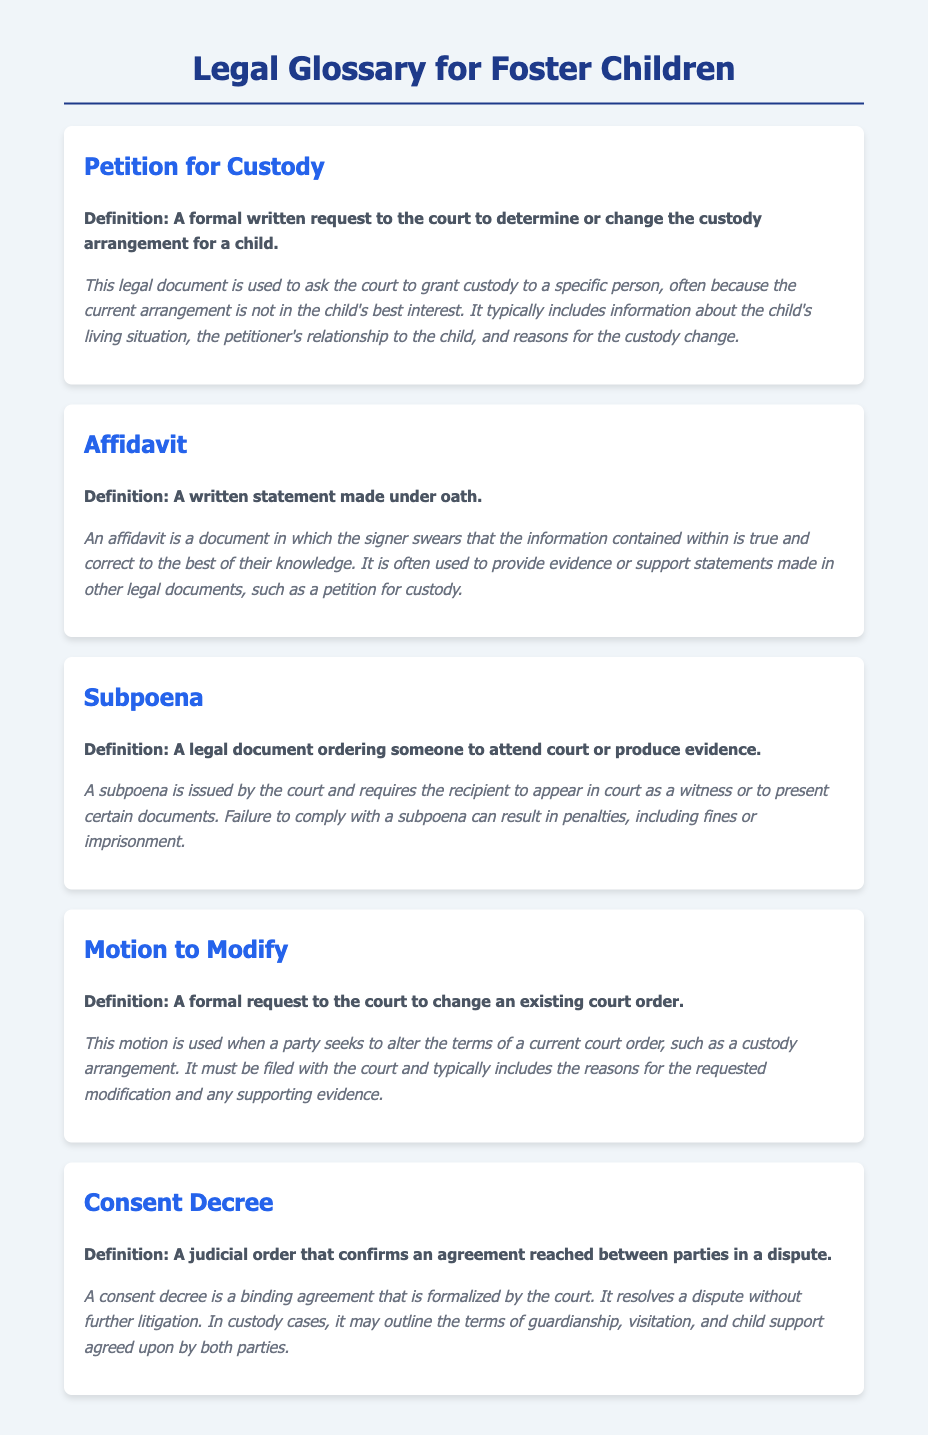What is a Petition for Custody? A Petition for Custody is a formal written request to the court to determine or change the custody arrangement for a child.
Answer: formal written request What does an Affidavit provide? An Affidavit provides a written statement made under oath to support statements made in other legal documents.
Answer: evidence or support What is required by a Subpoena? A Subpoena requires someone to attend court or produce evidence.
Answer: attend court What does a Motion to Modify seek? A Motion to Modify seeks to change an existing court order.
Answer: change an existing court order What is confirmed by a Consent Decree? A Consent Decree confirms an agreement reached between parties in a dispute.
Answer: agreement reached What happens if one does not comply with a Subpoena? Failure to comply with a Subpoena can result in penalties, including fines or imprisonment.
Answer: penalties What kind of document is an Affidavit? An Affidavit is a written statement made under oath.
Answer: written statement What is needed to file a Motion to Modify? A Motion to Modify must include the reasons for the requested modification and any supporting evidence.
Answer: reasons and supporting evidence What type of agreement does a Consent Decree formalize? A Consent Decree formalizes a binding agreement reached between parties.
Answer: binding agreement 